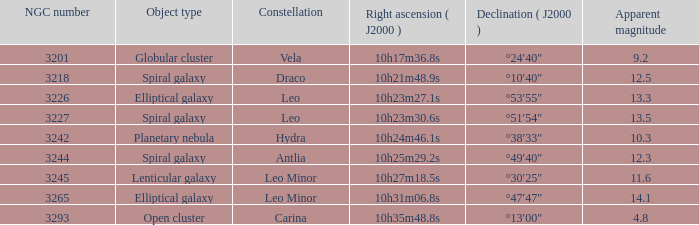What is the visible magnitude of a globular cluster? 9.2. 